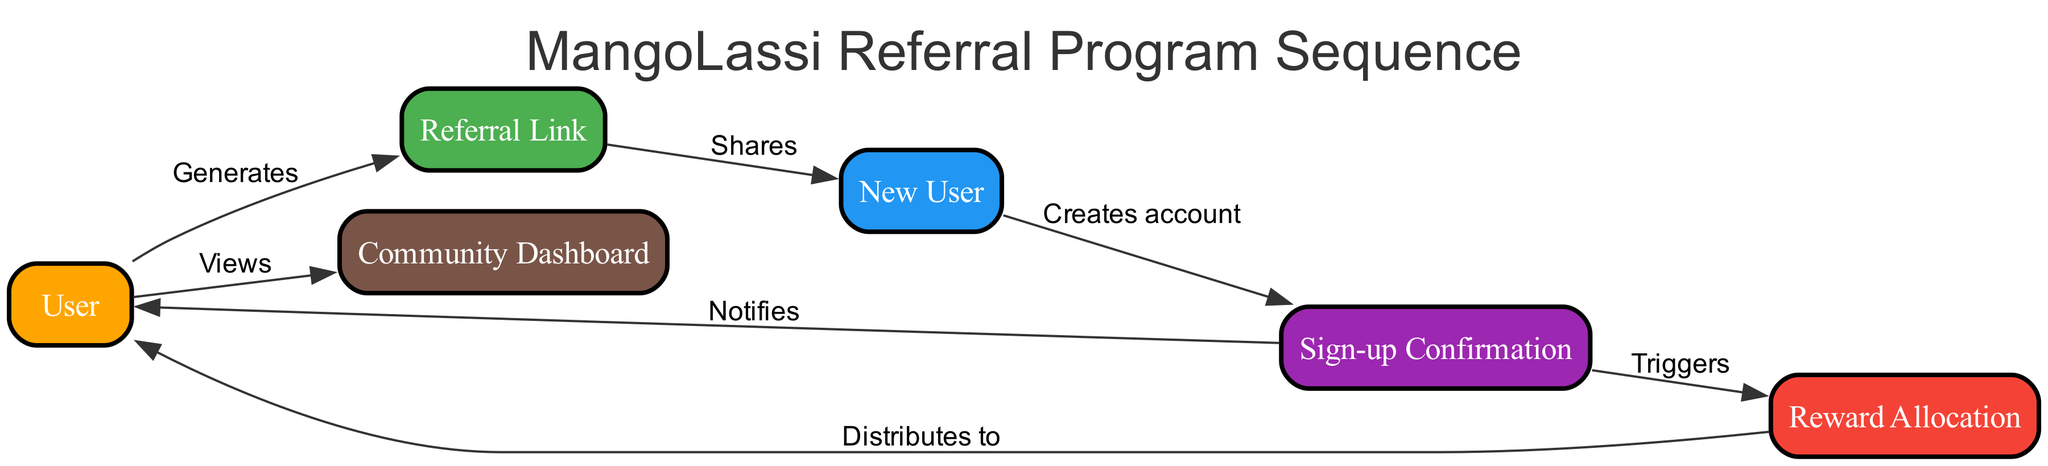What is the first action taken by the User? The first action taken by the User, as shown in the diagram, is generating a Referral Link. This is indicated by the directed edge from "User" to "Referral Link" labeled "Generates".
Answer: Generates How many main elements are there in the diagram? The diagram includes six main elements: User, Referral Link, New User, Sign-up Confirmation, Reward Allocation, and Community Dashboard. Therefore, the total count is six.
Answer: Six What does the New User do after clicking the Referral Link? After clicking the Referral Link, the New User creates an account. This process is indicated by the directed edge from "New User" to "Sign-up Confirmation" labeled "Creates account".
Answer: Creates account Which element gets notified after a New User successfully signs up? The element that gets notified after a New User successfully signs up is the User. This is shown by the directed edge from "Sign-up Confirmation" to "User" labeled "Notifies".
Answer: User What action triggers the Reward Allocation? The action that triggers Reward Allocation is the New User creating an account, which is shown through the directed edge from "Sign-up Confirmation" to "Reward Allocation" labeled "Triggers".
Answer: Creates account How does the User track their referrals and rewards? The User tracks their referrals and rewards through the Community Dashboard, as shown by the directed edge going from "User" to "Community Dashboard" labeled "Views".
Answer: Views What does the Reward Allocation distribute to the User? The Reward Allocation distributes rewards to the User, which includes items like points or discounts. This distribution is represented by the directed edge from "Reward Allocation" to "User" labeled "Distributes to".
Answer: Rewards What element represents the process of sharing the referral opportunity? The element that represents the process of sharing the referral opportunity is the Referral Link. This is shown in the diagram as the item to which the User generates and then shares with the New User.
Answer: Referral Link Which node confirms the successful sign-up of a New User? The node that confirms the successful sign-up of a New User is Sign-up Confirmation. This is indicated as the process following the New User's action of creating an account.
Answer: Sign-up Confirmation 